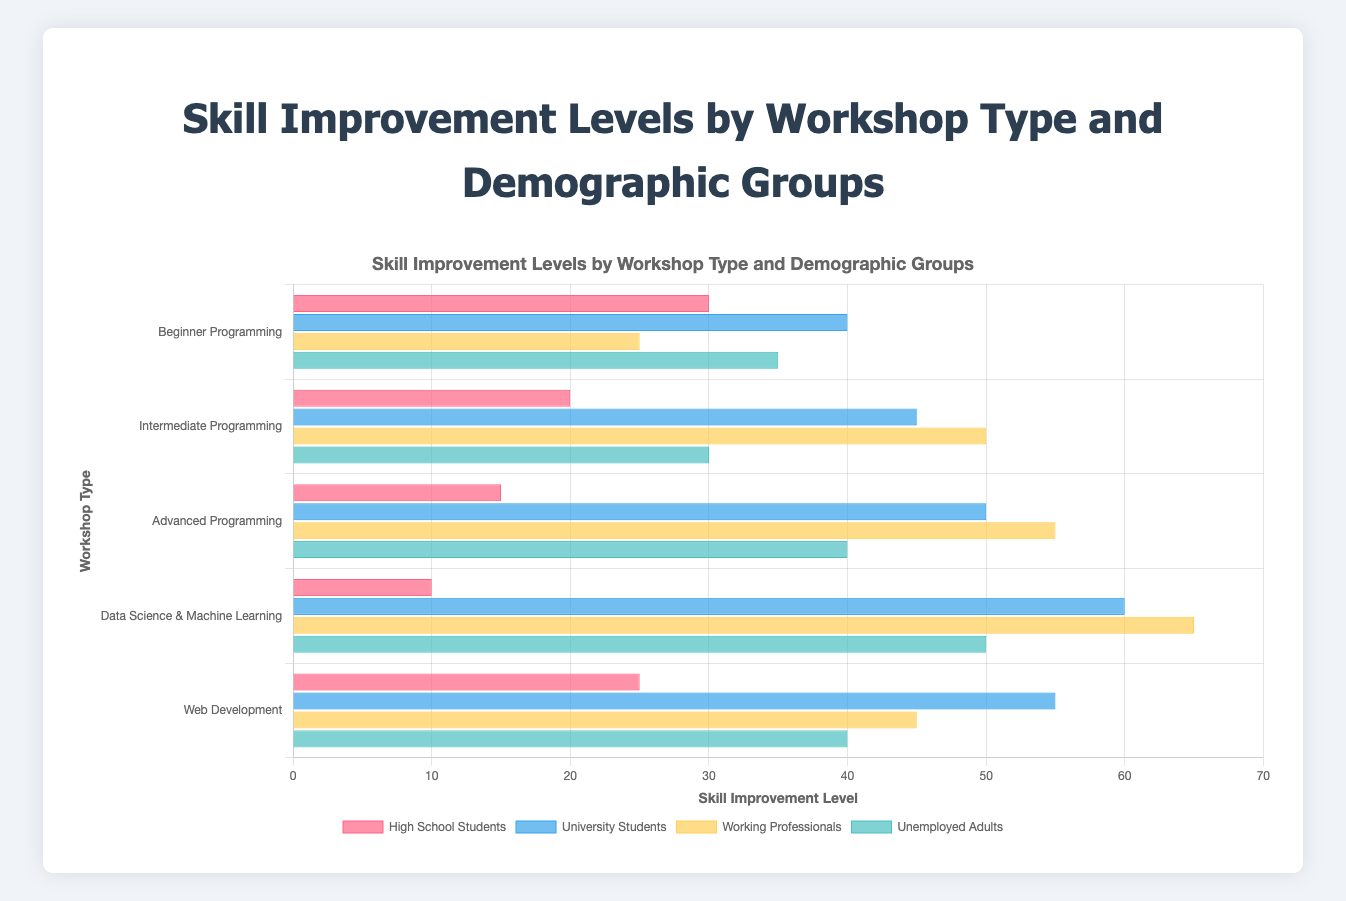Which demographic group shows the highest skill improvement in the "Data Science & Machine Learning" workshop? Look at the "Data Science & Machine Learning" section and identify which bar (demographic group) is the tallest.
Answer: Working Professionals Which workshop type has the lowest skill improvement level for high school students? Compare the bars representing high school students across different workshop types to identify the shortest one.
Answer: Data Science & Machine Learning Which demographic groups have a skill improvement of 45 in any workshop type? Go through all workshop types and find the bars with a height corresponding to a skill improvement of 45.
Answer: University Students in Web Development and Working Professionals in Intermediate Programming Which demographic group shows the least skill improvement in the "Advanced Programming" workshop? Look at the "Advanced Programming" section and find the shortest bar.
Answer: High School Students What is the total skill improvement for University Students in all workshop types? Sum up the skill improvement levels for University Students across all workshop types: 40 (Beginner) + 45 (Intermediate) + 50 (Advanced) + 60 (Data Science) + 55 (Web Development).
Answer: 250 Which workshop type shows the greatest difference in skill improvement between High School Students and University Students? Calculate the difference in skill improvement between High School Students and University Students for each workshop type: Beginner (40 - 30 = 10), Intermediate (45 - 20 = 25), Advanced (50 - 15 = 35), Data Science (60 - 10 = 50), Web Development (55 - 25 = 30), and identify the greatest value.
Answer: Data Science & Machine Learning Compare the skill improvement levels of Unemployed Adults in "Beginner Programming" and "Intermediate Programming". Which one is higher? Look at the bars representing Unemployed Adults in both "Beginner Programming" and "Intermediate Programming" and compare their heights.
Answer: Beginner Programming What is the average skill improvement level for Working Professionals across all workshops? Sum the skill improvements for Working Professionals in all workshop types and divide by the number of workshops: (25 + 50 + 55 + 65 + 45) / 5. Calculate the average.
Answer: 48 Which demographic group has the most consistent (smallest range of) skill improvement across all workshop types? Calculate the range (maximum - minimum) of skill improvement for each demographic group across all workshop types. The group with the smallest range is most consistent.
Answer: University Students In which workshop type do Unemployed Adults and Working Professionals have an equal skill improvement level? Identify the workshop type where the bars representing Unemployed Adults and Working Professionals have the same height.
Answer: None 